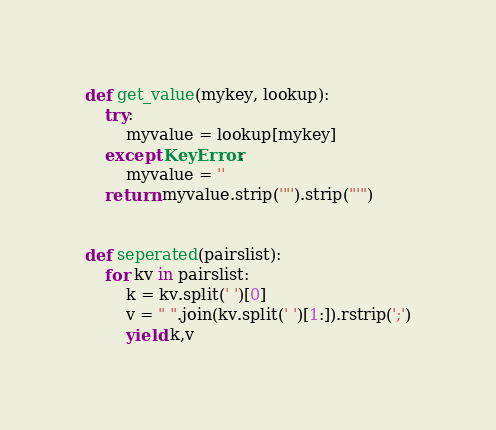Convert code to text. <code><loc_0><loc_0><loc_500><loc_500><_Python_>
def get_value(mykey, lookup):
	try:
		myvalue = lookup[mykey]
	except KeyError:
		myvalue = ''
	return myvalue.strip('"').strip("'")


def seperated(pairslist):
	for kv in pairslist:
		k = kv.split(' ')[0]
		v = " ".join(kv.split(' ')[1:]).rstrip(';')
		yield k,v

</code> 